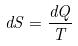Convert formula to latex. <formula><loc_0><loc_0><loc_500><loc_500>d S = \frac { d Q } { T }</formula> 